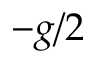Convert formula to latex. <formula><loc_0><loc_0><loc_500><loc_500>- g / 2</formula> 